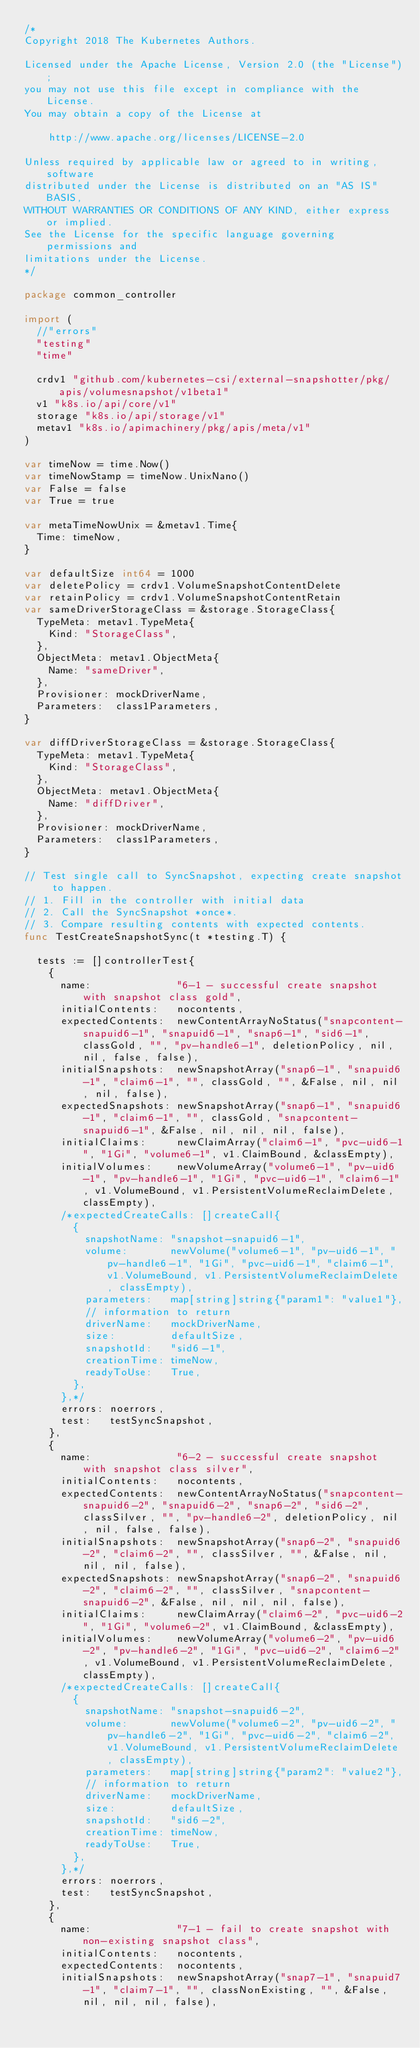Convert code to text. <code><loc_0><loc_0><loc_500><loc_500><_Go_>/*
Copyright 2018 The Kubernetes Authors.

Licensed under the Apache License, Version 2.0 (the "License");
you may not use this file except in compliance with the License.
You may obtain a copy of the License at

    http://www.apache.org/licenses/LICENSE-2.0

Unless required by applicable law or agreed to in writing, software
distributed under the License is distributed on an "AS IS" BASIS,
WITHOUT WARRANTIES OR CONDITIONS OF ANY KIND, either express or implied.
See the License for the specific language governing permissions and
limitations under the License.
*/

package common_controller

import (
	//"errors"
	"testing"
	"time"

	crdv1 "github.com/kubernetes-csi/external-snapshotter/pkg/apis/volumesnapshot/v1beta1"
	v1 "k8s.io/api/core/v1"
	storage "k8s.io/api/storage/v1"
	metav1 "k8s.io/apimachinery/pkg/apis/meta/v1"
)

var timeNow = time.Now()
var timeNowStamp = timeNow.UnixNano()
var False = false
var True = true

var metaTimeNowUnix = &metav1.Time{
	Time: timeNow,
}

var defaultSize int64 = 1000
var deletePolicy = crdv1.VolumeSnapshotContentDelete
var retainPolicy = crdv1.VolumeSnapshotContentRetain
var sameDriverStorageClass = &storage.StorageClass{
	TypeMeta: metav1.TypeMeta{
		Kind: "StorageClass",
	},
	ObjectMeta: metav1.ObjectMeta{
		Name: "sameDriver",
	},
	Provisioner: mockDriverName,
	Parameters:  class1Parameters,
}

var diffDriverStorageClass = &storage.StorageClass{
	TypeMeta: metav1.TypeMeta{
		Kind: "StorageClass",
	},
	ObjectMeta: metav1.ObjectMeta{
		Name: "diffDriver",
	},
	Provisioner: mockDriverName,
	Parameters:  class1Parameters,
}

// Test single call to SyncSnapshot, expecting create snapshot to happen.
// 1. Fill in the controller with initial data
// 2. Call the SyncSnapshot *once*.
// 3. Compare resulting contents with expected contents.
func TestCreateSnapshotSync(t *testing.T) {

	tests := []controllerTest{
		{
			name:              "6-1 - successful create snapshot with snapshot class gold",
			initialContents:   nocontents,
			expectedContents:  newContentArrayNoStatus("snapcontent-snapuid6-1", "snapuid6-1", "snap6-1", "sid6-1", classGold, "", "pv-handle6-1", deletionPolicy, nil, nil, false, false),
			initialSnapshots:  newSnapshotArray("snap6-1", "snapuid6-1", "claim6-1", "", classGold, "", &False, nil, nil, nil, false),
			expectedSnapshots: newSnapshotArray("snap6-1", "snapuid6-1", "claim6-1", "", classGold, "snapcontent-snapuid6-1", &False, nil, nil, nil, false),
			initialClaims:     newClaimArray("claim6-1", "pvc-uid6-1", "1Gi", "volume6-1", v1.ClaimBound, &classEmpty),
			initialVolumes:    newVolumeArray("volume6-1", "pv-uid6-1", "pv-handle6-1", "1Gi", "pvc-uid6-1", "claim6-1", v1.VolumeBound, v1.PersistentVolumeReclaimDelete, classEmpty),
			/*expectedCreateCalls: []createCall{
				{
					snapshotName: "snapshot-snapuid6-1",
					volume:       newVolume("volume6-1", "pv-uid6-1", "pv-handle6-1", "1Gi", "pvc-uid6-1", "claim6-1", v1.VolumeBound, v1.PersistentVolumeReclaimDelete, classEmpty),
					parameters:   map[string]string{"param1": "value1"},
					// information to return
					driverName:   mockDriverName,
					size:         defaultSize,
					snapshotId:   "sid6-1",
					creationTime: timeNow,
					readyToUse:   True,
				},
			},*/
			errors: noerrors,
			test:   testSyncSnapshot,
		},
		{
			name:              "6-2 - successful create snapshot with snapshot class silver",
			initialContents:   nocontents,
			expectedContents:  newContentArrayNoStatus("snapcontent-snapuid6-2", "snapuid6-2", "snap6-2", "sid6-2", classSilver, "", "pv-handle6-2", deletionPolicy, nil, nil, false, false),
			initialSnapshots:  newSnapshotArray("snap6-2", "snapuid6-2", "claim6-2", "", classSilver, "", &False, nil, nil, nil, false),
			expectedSnapshots: newSnapshotArray("snap6-2", "snapuid6-2", "claim6-2", "", classSilver, "snapcontent-snapuid6-2", &False, nil, nil, nil, false),
			initialClaims:     newClaimArray("claim6-2", "pvc-uid6-2", "1Gi", "volume6-2", v1.ClaimBound, &classEmpty),
			initialVolumes:    newVolumeArray("volume6-2", "pv-uid6-2", "pv-handle6-2", "1Gi", "pvc-uid6-2", "claim6-2", v1.VolumeBound, v1.PersistentVolumeReclaimDelete, classEmpty),
			/*expectedCreateCalls: []createCall{
				{
					snapshotName: "snapshot-snapuid6-2",
					volume:       newVolume("volume6-2", "pv-uid6-2", "pv-handle6-2", "1Gi", "pvc-uid6-2", "claim6-2", v1.VolumeBound, v1.PersistentVolumeReclaimDelete, classEmpty),
					parameters:   map[string]string{"param2": "value2"},
					// information to return
					driverName:   mockDriverName,
					size:         defaultSize,
					snapshotId:   "sid6-2",
					creationTime: timeNow,
					readyToUse:   True,
				},
			},*/
			errors: noerrors,
			test:   testSyncSnapshot,
		},
		{
			name:              "7-1 - fail to create snapshot with non-existing snapshot class",
			initialContents:   nocontents,
			expectedContents:  nocontents,
			initialSnapshots:  newSnapshotArray("snap7-1", "snapuid7-1", "claim7-1", "", classNonExisting, "", &False, nil, nil, nil, false),</code> 